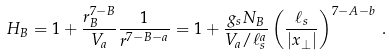Convert formula to latex. <formula><loc_0><loc_0><loc_500><loc_500>H _ { B } = 1 + { \frac { r _ { B } ^ { 7 - B } } { V _ { a } } } { \frac { 1 } { r ^ { 7 - B - a } } } = 1 + { \frac { g _ { s } N _ { B } } { V _ { a } / \ell _ { s } ^ { a } } } \left ( { \frac { \ell _ { s } } { | x _ { \perp } | } } \right ) ^ { 7 - A - b } \, .</formula> 